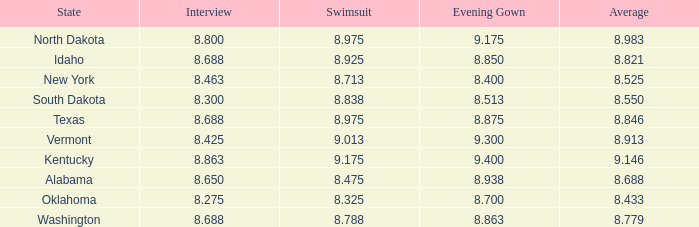What is the lowest average of the contestant with an interview of 8.275 and an evening gown bigger than 8.7? None. 